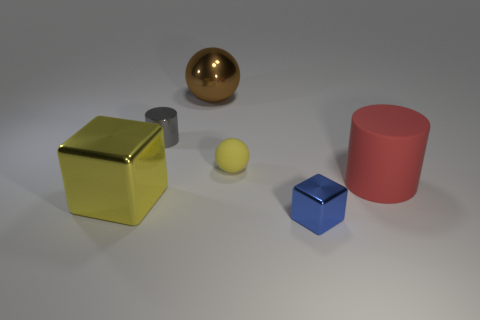Add 2 large yellow cubes. How many objects exist? 8 Subtract 1 blocks. How many blocks are left? 1 Subtract all cubes. How many objects are left? 4 Subtract all green spheres. Subtract all red cylinders. How many spheres are left? 2 Subtract all brown cylinders. How many yellow balls are left? 1 Subtract all red matte objects. Subtract all brown metal things. How many objects are left? 4 Add 2 tiny yellow rubber spheres. How many tiny yellow rubber spheres are left? 3 Add 2 big brown cubes. How many big brown cubes exist? 2 Subtract 1 red cylinders. How many objects are left? 5 